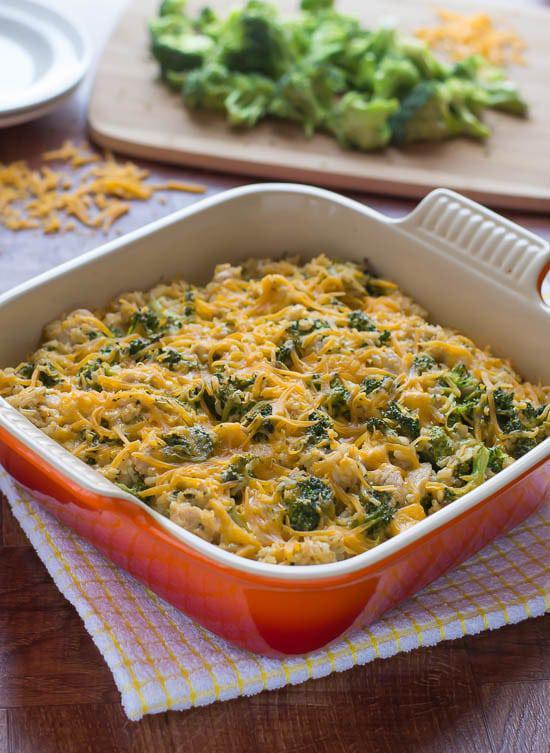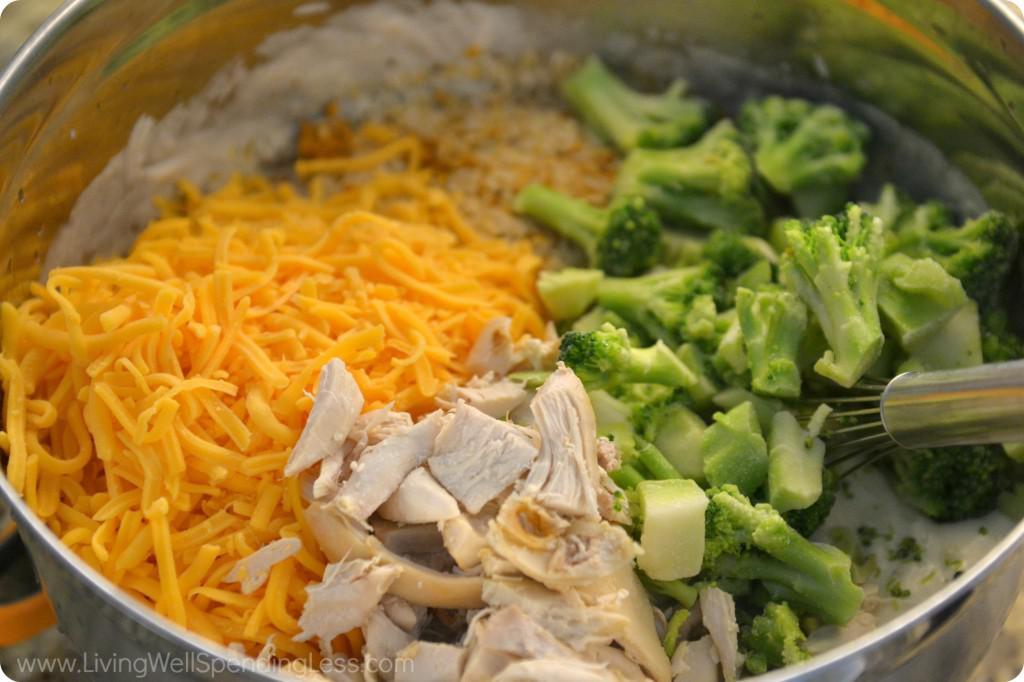The first image is the image on the left, the second image is the image on the right. Considering the images on both sides, is "A meal is served on a red container." valid? Answer yes or no. Yes. 